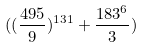Convert formula to latex. <formula><loc_0><loc_0><loc_500><loc_500>( ( \frac { 4 9 5 } { 9 } ) ^ { 1 3 1 } + \frac { 1 8 3 ^ { 6 } } { 3 } )</formula> 